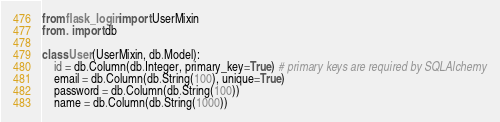Convert code to text. <code><loc_0><loc_0><loc_500><loc_500><_Python_>from flask_login import UserMixin
from . import db

class User(UserMixin, db.Model):
    id = db.Column(db.Integer, primary_key=True) # primary keys are required by SQLAlchemy
    email = db.Column(db.String(100), unique=True)
    password = db.Column(db.String(100))
    name = db.Column(db.String(1000))</code> 